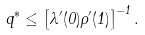<formula> <loc_0><loc_0><loc_500><loc_500>q ^ { * } \leq \left [ \lambda ^ { \prime } ( 0 ) \rho ^ { \prime } ( 1 ) \right ] ^ { - 1 } .</formula> 